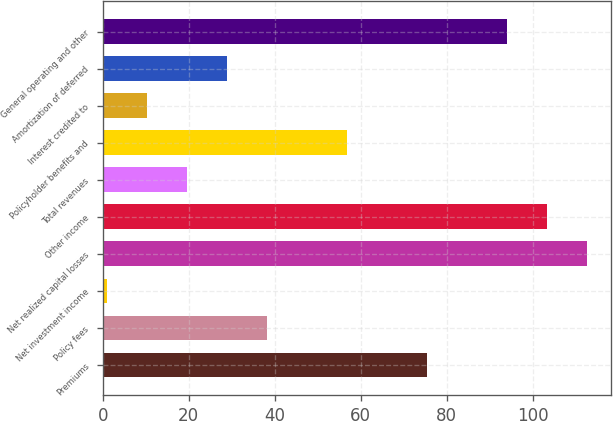Convert chart to OTSL. <chart><loc_0><loc_0><loc_500><loc_500><bar_chart><fcel>Premiums<fcel>Policy fees<fcel>Net investment income<fcel>Net realized capital losses<fcel>Other income<fcel>Total revenues<fcel>Policyholder benefits and<fcel>Interest credited to<fcel>Amortization of deferred<fcel>General operating and other<nl><fcel>75.4<fcel>38.2<fcel>1<fcel>112.6<fcel>103.3<fcel>19.6<fcel>56.8<fcel>10.3<fcel>28.9<fcel>94<nl></chart> 